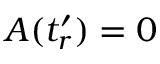<formula> <loc_0><loc_0><loc_500><loc_500>A ( t _ { r } ^ { \prime } ) = 0</formula> 